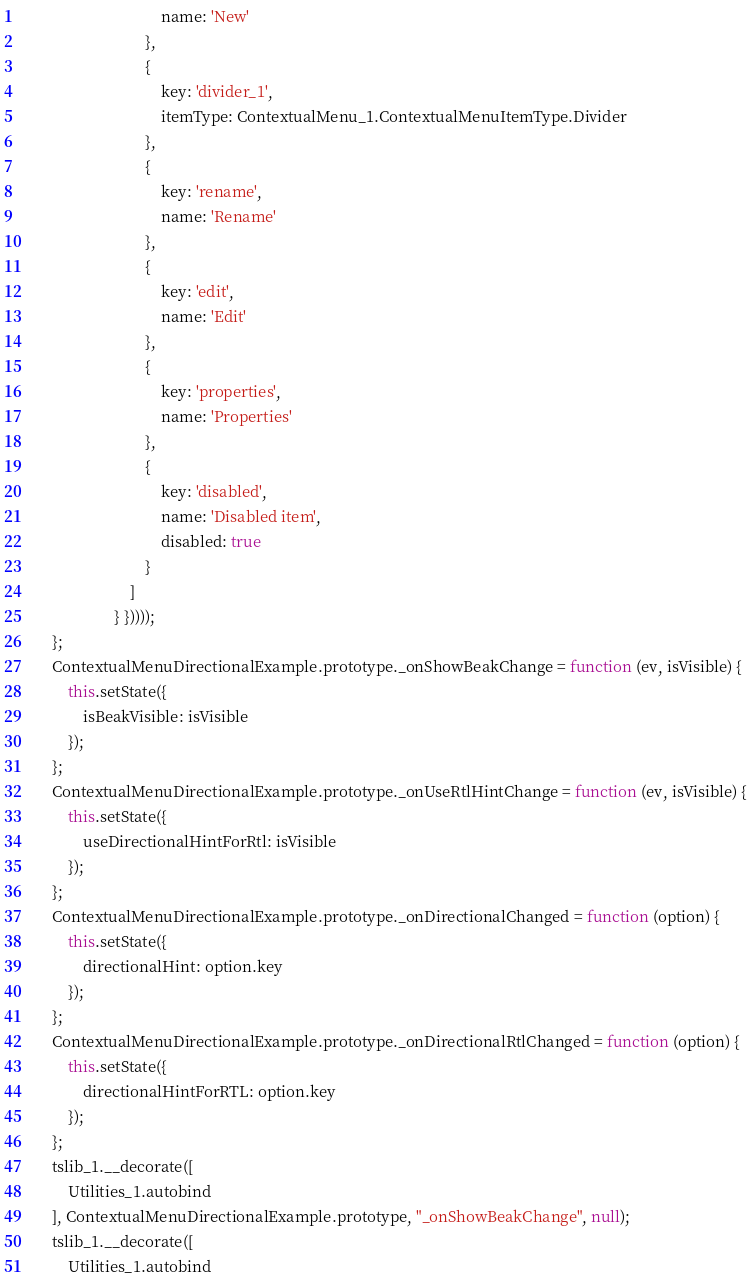Convert code to text. <code><loc_0><loc_0><loc_500><loc_500><_JavaScript_>                                    name: 'New'
                                },
                                {
                                    key: 'divider_1',
                                    itemType: ContextualMenu_1.ContextualMenuItemType.Divider
                                },
                                {
                                    key: 'rename',
                                    name: 'Rename'
                                },
                                {
                                    key: 'edit',
                                    name: 'Edit'
                                },
                                {
                                    key: 'properties',
                                    name: 'Properties'
                                },
                                {
                                    key: 'disabled',
                                    name: 'Disabled item',
                                    disabled: true
                                }
                            ]
                        } }))));
        };
        ContextualMenuDirectionalExample.prototype._onShowBeakChange = function (ev, isVisible) {
            this.setState({
                isBeakVisible: isVisible
            });
        };
        ContextualMenuDirectionalExample.prototype._onUseRtlHintChange = function (ev, isVisible) {
            this.setState({
                useDirectionalHintForRtl: isVisible
            });
        };
        ContextualMenuDirectionalExample.prototype._onDirectionalChanged = function (option) {
            this.setState({
                directionalHint: option.key
            });
        };
        ContextualMenuDirectionalExample.prototype._onDirectionalRtlChanged = function (option) {
            this.setState({
                directionalHintForRTL: option.key
            });
        };
        tslib_1.__decorate([
            Utilities_1.autobind
        ], ContextualMenuDirectionalExample.prototype, "_onShowBeakChange", null);
        tslib_1.__decorate([
            Utilities_1.autobind</code> 